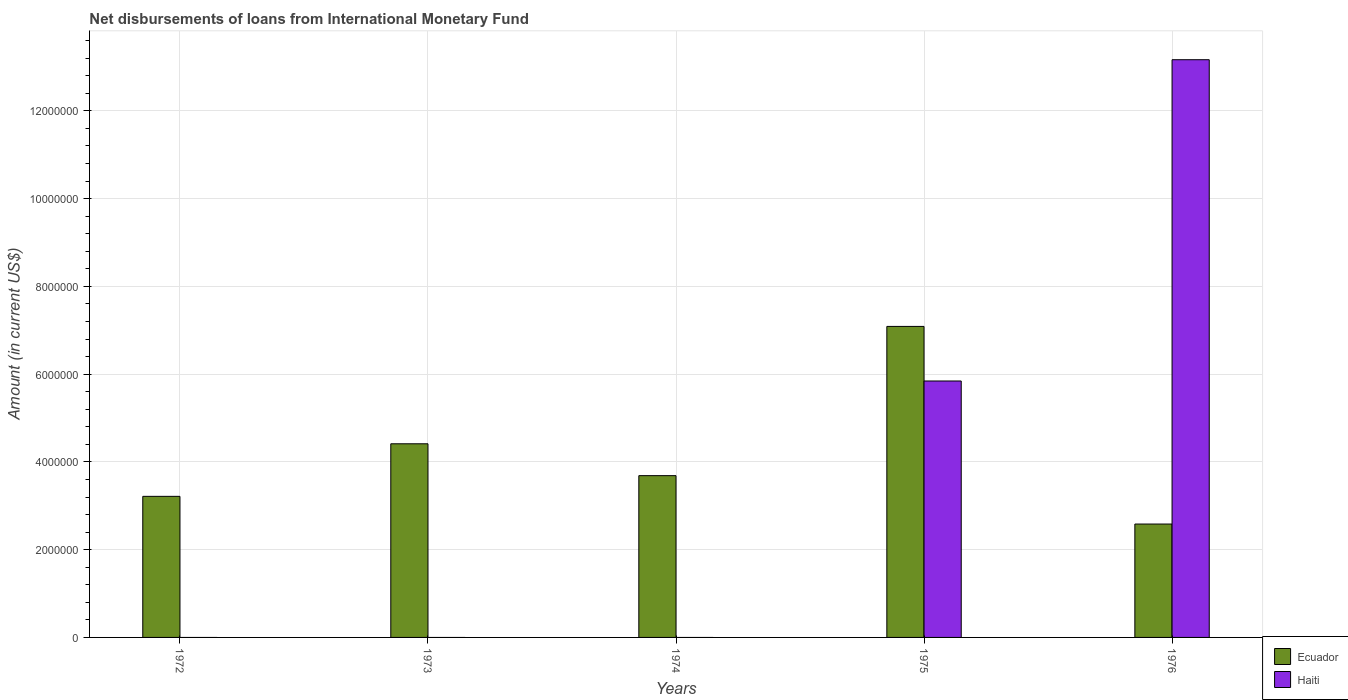Are the number of bars per tick equal to the number of legend labels?
Your answer should be compact. No. How many bars are there on the 1st tick from the left?
Offer a very short reply. 1. How many bars are there on the 5th tick from the right?
Your answer should be very brief. 1. In how many cases, is the number of bars for a given year not equal to the number of legend labels?
Your response must be concise. 3. What is the amount of loans disbursed in Ecuador in 1972?
Your answer should be compact. 3.22e+06. Across all years, what is the maximum amount of loans disbursed in Ecuador?
Give a very brief answer. 7.09e+06. Across all years, what is the minimum amount of loans disbursed in Ecuador?
Ensure brevity in your answer.  2.58e+06. In which year was the amount of loans disbursed in Haiti maximum?
Give a very brief answer. 1976. What is the total amount of loans disbursed in Haiti in the graph?
Provide a succinct answer. 1.90e+07. What is the difference between the amount of loans disbursed in Ecuador in 1974 and that in 1975?
Your answer should be compact. -3.40e+06. What is the difference between the amount of loans disbursed in Haiti in 1973 and the amount of loans disbursed in Ecuador in 1975?
Ensure brevity in your answer.  -7.09e+06. What is the average amount of loans disbursed in Ecuador per year?
Offer a terse response. 4.20e+06. In the year 1976, what is the difference between the amount of loans disbursed in Ecuador and amount of loans disbursed in Haiti?
Provide a succinct answer. -1.06e+07. In how many years, is the amount of loans disbursed in Haiti greater than 3200000 US$?
Make the answer very short. 2. What is the ratio of the amount of loans disbursed in Ecuador in 1973 to that in 1975?
Offer a very short reply. 0.62. Is the amount of loans disbursed in Ecuador in 1974 less than that in 1976?
Offer a terse response. No. Is the difference between the amount of loans disbursed in Ecuador in 1975 and 1976 greater than the difference between the amount of loans disbursed in Haiti in 1975 and 1976?
Provide a short and direct response. Yes. What is the difference between the highest and the second highest amount of loans disbursed in Ecuador?
Your answer should be compact. 2.68e+06. What is the difference between the highest and the lowest amount of loans disbursed in Ecuador?
Your answer should be very brief. 4.50e+06. In how many years, is the amount of loans disbursed in Ecuador greater than the average amount of loans disbursed in Ecuador taken over all years?
Your answer should be compact. 2. Is the sum of the amount of loans disbursed in Ecuador in 1972 and 1974 greater than the maximum amount of loans disbursed in Haiti across all years?
Your answer should be compact. No. Are all the bars in the graph horizontal?
Offer a very short reply. No. How many years are there in the graph?
Your answer should be compact. 5. What is the difference between two consecutive major ticks on the Y-axis?
Keep it short and to the point. 2.00e+06. Are the values on the major ticks of Y-axis written in scientific E-notation?
Your answer should be very brief. No. Does the graph contain any zero values?
Your answer should be very brief. Yes. Does the graph contain grids?
Make the answer very short. Yes. How many legend labels are there?
Provide a succinct answer. 2. What is the title of the graph?
Keep it short and to the point. Net disbursements of loans from International Monetary Fund. What is the label or title of the X-axis?
Give a very brief answer. Years. What is the label or title of the Y-axis?
Make the answer very short. Amount (in current US$). What is the Amount (in current US$) in Ecuador in 1972?
Ensure brevity in your answer.  3.22e+06. What is the Amount (in current US$) of Haiti in 1972?
Offer a terse response. 0. What is the Amount (in current US$) of Ecuador in 1973?
Provide a succinct answer. 4.41e+06. What is the Amount (in current US$) in Haiti in 1973?
Your response must be concise. 0. What is the Amount (in current US$) in Ecuador in 1974?
Offer a very short reply. 3.69e+06. What is the Amount (in current US$) of Haiti in 1974?
Provide a succinct answer. 0. What is the Amount (in current US$) of Ecuador in 1975?
Give a very brief answer. 7.09e+06. What is the Amount (in current US$) in Haiti in 1975?
Provide a short and direct response. 5.84e+06. What is the Amount (in current US$) of Ecuador in 1976?
Provide a succinct answer. 2.58e+06. What is the Amount (in current US$) in Haiti in 1976?
Provide a succinct answer. 1.32e+07. Across all years, what is the maximum Amount (in current US$) of Ecuador?
Make the answer very short. 7.09e+06. Across all years, what is the maximum Amount (in current US$) in Haiti?
Ensure brevity in your answer.  1.32e+07. Across all years, what is the minimum Amount (in current US$) in Ecuador?
Provide a short and direct response. 2.58e+06. Across all years, what is the minimum Amount (in current US$) of Haiti?
Offer a terse response. 0. What is the total Amount (in current US$) in Ecuador in the graph?
Your answer should be compact. 2.10e+07. What is the total Amount (in current US$) of Haiti in the graph?
Your answer should be very brief. 1.90e+07. What is the difference between the Amount (in current US$) of Ecuador in 1972 and that in 1973?
Your answer should be compact. -1.20e+06. What is the difference between the Amount (in current US$) in Ecuador in 1972 and that in 1974?
Offer a terse response. -4.72e+05. What is the difference between the Amount (in current US$) of Ecuador in 1972 and that in 1975?
Your answer should be compact. -3.87e+06. What is the difference between the Amount (in current US$) of Ecuador in 1972 and that in 1976?
Provide a short and direct response. 6.31e+05. What is the difference between the Amount (in current US$) of Ecuador in 1973 and that in 1974?
Give a very brief answer. 7.26e+05. What is the difference between the Amount (in current US$) of Ecuador in 1973 and that in 1975?
Your answer should be compact. -2.68e+06. What is the difference between the Amount (in current US$) in Ecuador in 1973 and that in 1976?
Make the answer very short. 1.83e+06. What is the difference between the Amount (in current US$) of Ecuador in 1974 and that in 1975?
Your answer should be very brief. -3.40e+06. What is the difference between the Amount (in current US$) of Ecuador in 1974 and that in 1976?
Provide a succinct answer. 1.10e+06. What is the difference between the Amount (in current US$) in Ecuador in 1975 and that in 1976?
Provide a succinct answer. 4.50e+06. What is the difference between the Amount (in current US$) in Haiti in 1975 and that in 1976?
Provide a short and direct response. -7.32e+06. What is the difference between the Amount (in current US$) of Ecuador in 1972 and the Amount (in current US$) of Haiti in 1975?
Provide a short and direct response. -2.63e+06. What is the difference between the Amount (in current US$) of Ecuador in 1972 and the Amount (in current US$) of Haiti in 1976?
Keep it short and to the point. -9.95e+06. What is the difference between the Amount (in current US$) of Ecuador in 1973 and the Amount (in current US$) of Haiti in 1975?
Your answer should be very brief. -1.43e+06. What is the difference between the Amount (in current US$) of Ecuador in 1973 and the Amount (in current US$) of Haiti in 1976?
Make the answer very short. -8.75e+06. What is the difference between the Amount (in current US$) in Ecuador in 1974 and the Amount (in current US$) in Haiti in 1975?
Your answer should be compact. -2.16e+06. What is the difference between the Amount (in current US$) in Ecuador in 1974 and the Amount (in current US$) in Haiti in 1976?
Your answer should be very brief. -9.48e+06. What is the difference between the Amount (in current US$) of Ecuador in 1975 and the Amount (in current US$) of Haiti in 1976?
Keep it short and to the point. -6.08e+06. What is the average Amount (in current US$) of Ecuador per year?
Your response must be concise. 4.20e+06. What is the average Amount (in current US$) in Haiti per year?
Offer a very short reply. 3.80e+06. In the year 1975, what is the difference between the Amount (in current US$) of Ecuador and Amount (in current US$) of Haiti?
Offer a terse response. 1.24e+06. In the year 1976, what is the difference between the Amount (in current US$) of Ecuador and Amount (in current US$) of Haiti?
Provide a short and direct response. -1.06e+07. What is the ratio of the Amount (in current US$) in Ecuador in 1972 to that in 1973?
Make the answer very short. 0.73. What is the ratio of the Amount (in current US$) in Ecuador in 1972 to that in 1974?
Offer a terse response. 0.87. What is the ratio of the Amount (in current US$) in Ecuador in 1972 to that in 1975?
Offer a terse response. 0.45. What is the ratio of the Amount (in current US$) in Ecuador in 1972 to that in 1976?
Your answer should be very brief. 1.24. What is the ratio of the Amount (in current US$) of Ecuador in 1973 to that in 1974?
Provide a short and direct response. 1.2. What is the ratio of the Amount (in current US$) in Ecuador in 1973 to that in 1975?
Your answer should be very brief. 0.62. What is the ratio of the Amount (in current US$) of Ecuador in 1973 to that in 1976?
Ensure brevity in your answer.  1.71. What is the ratio of the Amount (in current US$) of Ecuador in 1974 to that in 1975?
Provide a succinct answer. 0.52. What is the ratio of the Amount (in current US$) of Ecuador in 1974 to that in 1976?
Your answer should be compact. 1.43. What is the ratio of the Amount (in current US$) in Ecuador in 1975 to that in 1976?
Offer a terse response. 2.74. What is the ratio of the Amount (in current US$) in Haiti in 1975 to that in 1976?
Your answer should be very brief. 0.44. What is the difference between the highest and the second highest Amount (in current US$) in Ecuador?
Your response must be concise. 2.68e+06. What is the difference between the highest and the lowest Amount (in current US$) of Ecuador?
Offer a very short reply. 4.50e+06. What is the difference between the highest and the lowest Amount (in current US$) in Haiti?
Offer a terse response. 1.32e+07. 